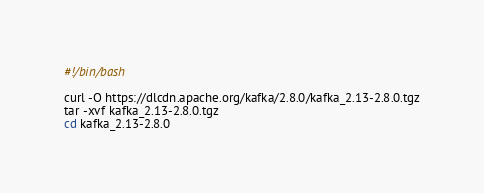Convert code to text. <code><loc_0><loc_0><loc_500><loc_500><_Bash_>#!/bin/bash

curl -O https://dlcdn.apache.org/kafka/2.8.0/kafka_2.13-2.8.0.tgz
tar -xvf kafka_2.13-2.8.0.tgz
cd kafka_2.13-2.8.0
</code> 